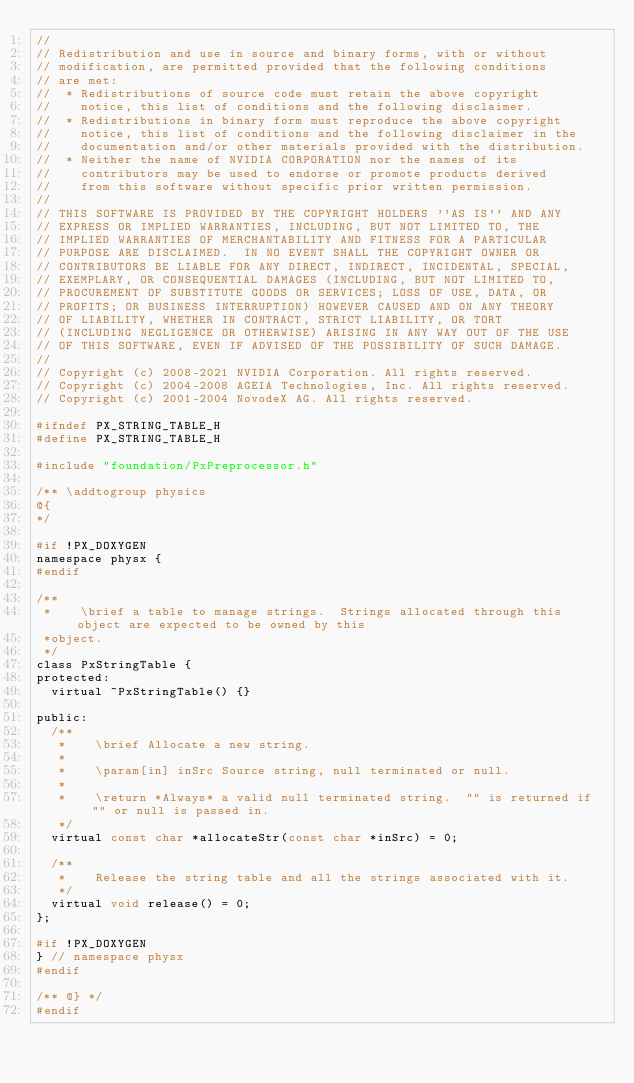<code> <loc_0><loc_0><loc_500><loc_500><_C_>//
// Redistribution and use in source and binary forms, with or without
// modification, are permitted provided that the following conditions
// are met:
//  * Redistributions of source code must retain the above copyright
//    notice, this list of conditions and the following disclaimer.
//  * Redistributions in binary form must reproduce the above copyright
//    notice, this list of conditions and the following disclaimer in the
//    documentation and/or other materials provided with the distribution.
//  * Neither the name of NVIDIA CORPORATION nor the names of its
//    contributors may be used to endorse or promote products derived
//    from this software without specific prior written permission.
//
// THIS SOFTWARE IS PROVIDED BY THE COPYRIGHT HOLDERS ''AS IS'' AND ANY
// EXPRESS OR IMPLIED WARRANTIES, INCLUDING, BUT NOT LIMITED TO, THE
// IMPLIED WARRANTIES OF MERCHANTABILITY AND FITNESS FOR A PARTICULAR
// PURPOSE ARE DISCLAIMED.  IN NO EVENT SHALL THE COPYRIGHT OWNER OR
// CONTRIBUTORS BE LIABLE FOR ANY DIRECT, INDIRECT, INCIDENTAL, SPECIAL,
// EXEMPLARY, OR CONSEQUENTIAL DAMAGES (INCLUDING, BUT NOT LIMITED TO,
// PROCUREMENT OF SUBSTITUTE GOODS OR SERVICES; LOSS OF USE, DATA, OR
// PROFITS; OR BUSINESS INTERRUPTION) HOWEVER CAUSED AND ON ANY THEORY
// OF LIABILITY, WHETHER IN CONTRACT, STRICT LIABILITY, OR TORT
// (INCLUDING NEGLIGENCE OR OTHERWISE) ARISING IN ANY WAY OUT OF THE USE
// OF THIS SOFTWARE, EVEN IF ADVISED OF THE POSSIBILITY OF SUCH DAMAGE.
//
// Copyright (c) 2008-2021 NVIDIA Corporation. All rights reserved.
// Copyright (c) 2004-2008 AGEIA Technologies, Inc. All rights reserved.
// Copyright (c) 2001-2004 NovodeX AG. All rights reserved.

#ifndef PX_STRING_TABLE_H
#define PX_STRING_TABLE_H

#include "foundation/PxPreprocessor.h"

/** \addtogroup physics
@{
*/

#if !PX_DOXYGEN
namespace physx {
#endif

/**
 *    \brief a table to manage strings.  Strings allocated through this object are expected to be owned by this
 *object.
 */
class PxStringTable {
protected:
  virtual ~PxStringTable() {}

public:
  /**
   *    \brief Allocate a new string.
   *
   *    \param[in] inSrc Source string, null terminated or null.
   *
   *    \return *Always* a valid null terminated string.  "" is returned if "" or null is passed in.
   */
  virtual const char *allocateStr(const char *inSrc) = 0;

  /**
   *    Release the string table and all the strings associated with it.
   */
  virtual void release() = 0;
};

#if !PX_DOXYGEN
} // namespace physx
#endif

/** @} */
#endif
</code> 